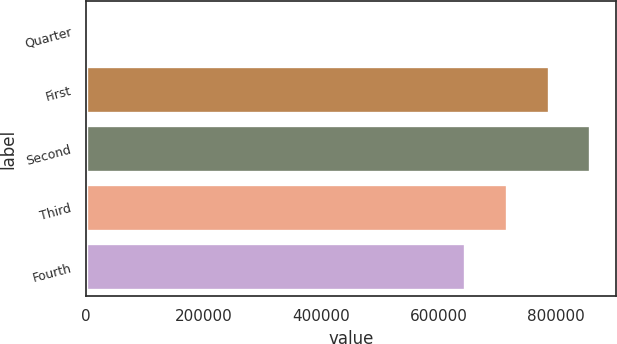Convert chart to OTSL. <chart><loc_0><loc_0><loc_500><loc_500><bar_chart><fcel>Quarter<fcel>First<fcel>Second<fcel>Third<fcel>Fourth<nl><fcel>2011<fcel>787099<fcel>858456<fcel>715741<fcel>644383<nl></chart> 